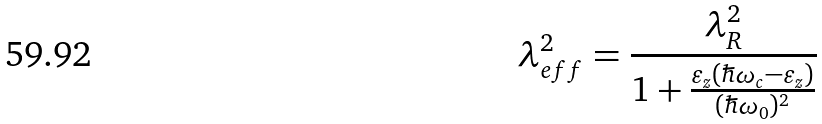Convert formula to latex. <formula><loc_0><loc_0><loc_500><loc_500>\lambda _ { e f f } ^ { 2 } = \frac { \lambda _ { R } ^ { 2 } } { 1 + \frac { \varepsilon _ { z } ( \hbar { \omega } _ { c } - \varepsilon _ { z } ) } { ( \hbar { \omega } _ { 0 } ) ^ { 2 } } }</formula> 